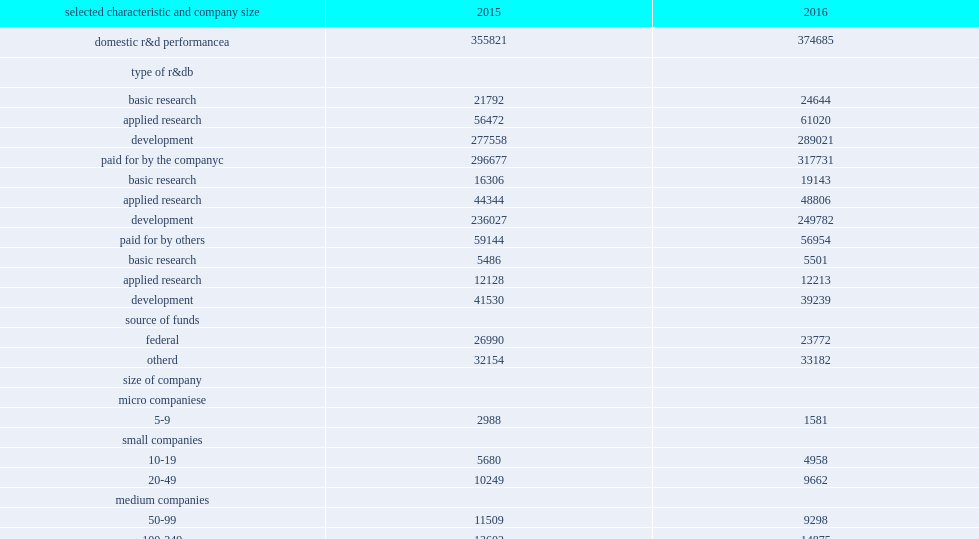How many million dollars did businesses spend on research and development performance in the united states in 2016? 374685.0. Businesses spent $375 billion on research and development performance in the united states in 2016, how many percentage points of increasing from 2015? 0.053015. How many million dollars was funding from the companies' own sources in 2016? 317731.0. Funding from the companies' own sources was $318 billion in 2016, how many percent of increasing from 2015? 0.070966. How many million dollars were funding from other sources in 2016? 56954.0. How many million dollars were funding from other sources in 2015? 59144.0. 